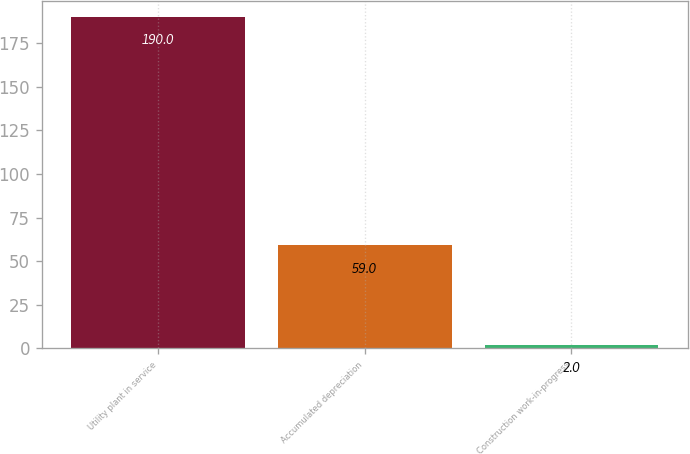Convert chart to OTSL. <chart><loc_0><loc_0><loc_500><loc_500><bar_chart><fcel>Utility plant in service<fcel>Accumulated depreciation<fcel>Construction work-in-progress<nl><fcel>190<fcel>59<fcel>2<nl></chart> 